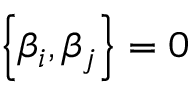Convert formula to latex. <formula><loc_0><loc_0><loc_500><loc_500>\left \{ \beta _ { i } , \beta _ { j } \right \} = 0</formula> 